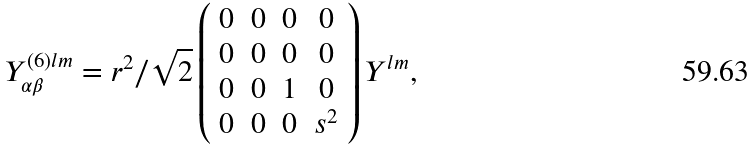Convert formula to latex. <formula><loc_0><loc_0><loc_500><loc_500>Y ^ { ( 6 ) l m } _ { \alpha \beta } = r ^ { 2 } / \sqrt { 2 } \left ( \begin{array} { c c c c } 0 & 0 & 0 & 0 \\ 0 & 0 & 0 & 0 \\ 0 & 0 & 1 & 0 \\ 0 & 0 & 0 & s ^ { 2 } \end{array} \right ) Y ^ { l m } ,</formula> 